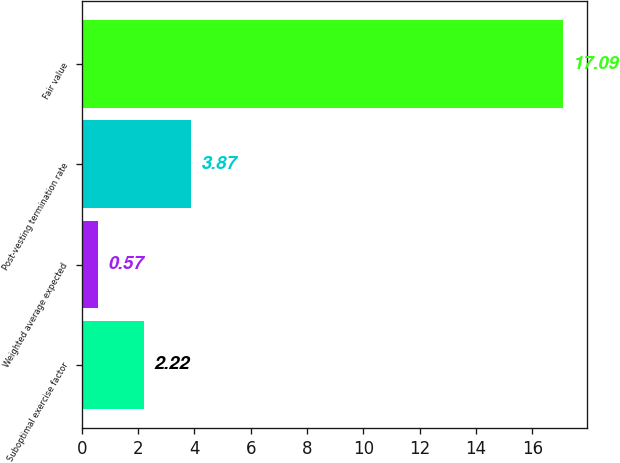Convert chart to OTSL. <chart><loc_0><loc_0><loc_500><loc_500><bar_chart><fcel>Suboptimal exercise factor<fcel>Weighted average expected<fcel>Post-vesting termination rate<fcel>Fair value<nl><fcel>2.22<fcel>0.57<fcel>3.87<fcel>17.09<nl></chart> 